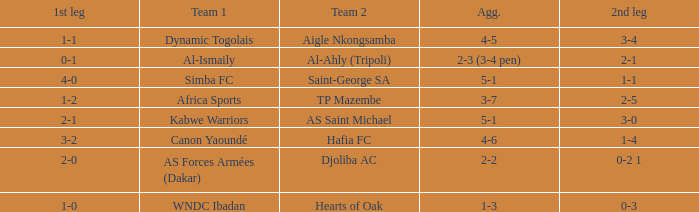When Kabwe Warriors (team 1) played, what was the result of the 1st leg? 2-1. 